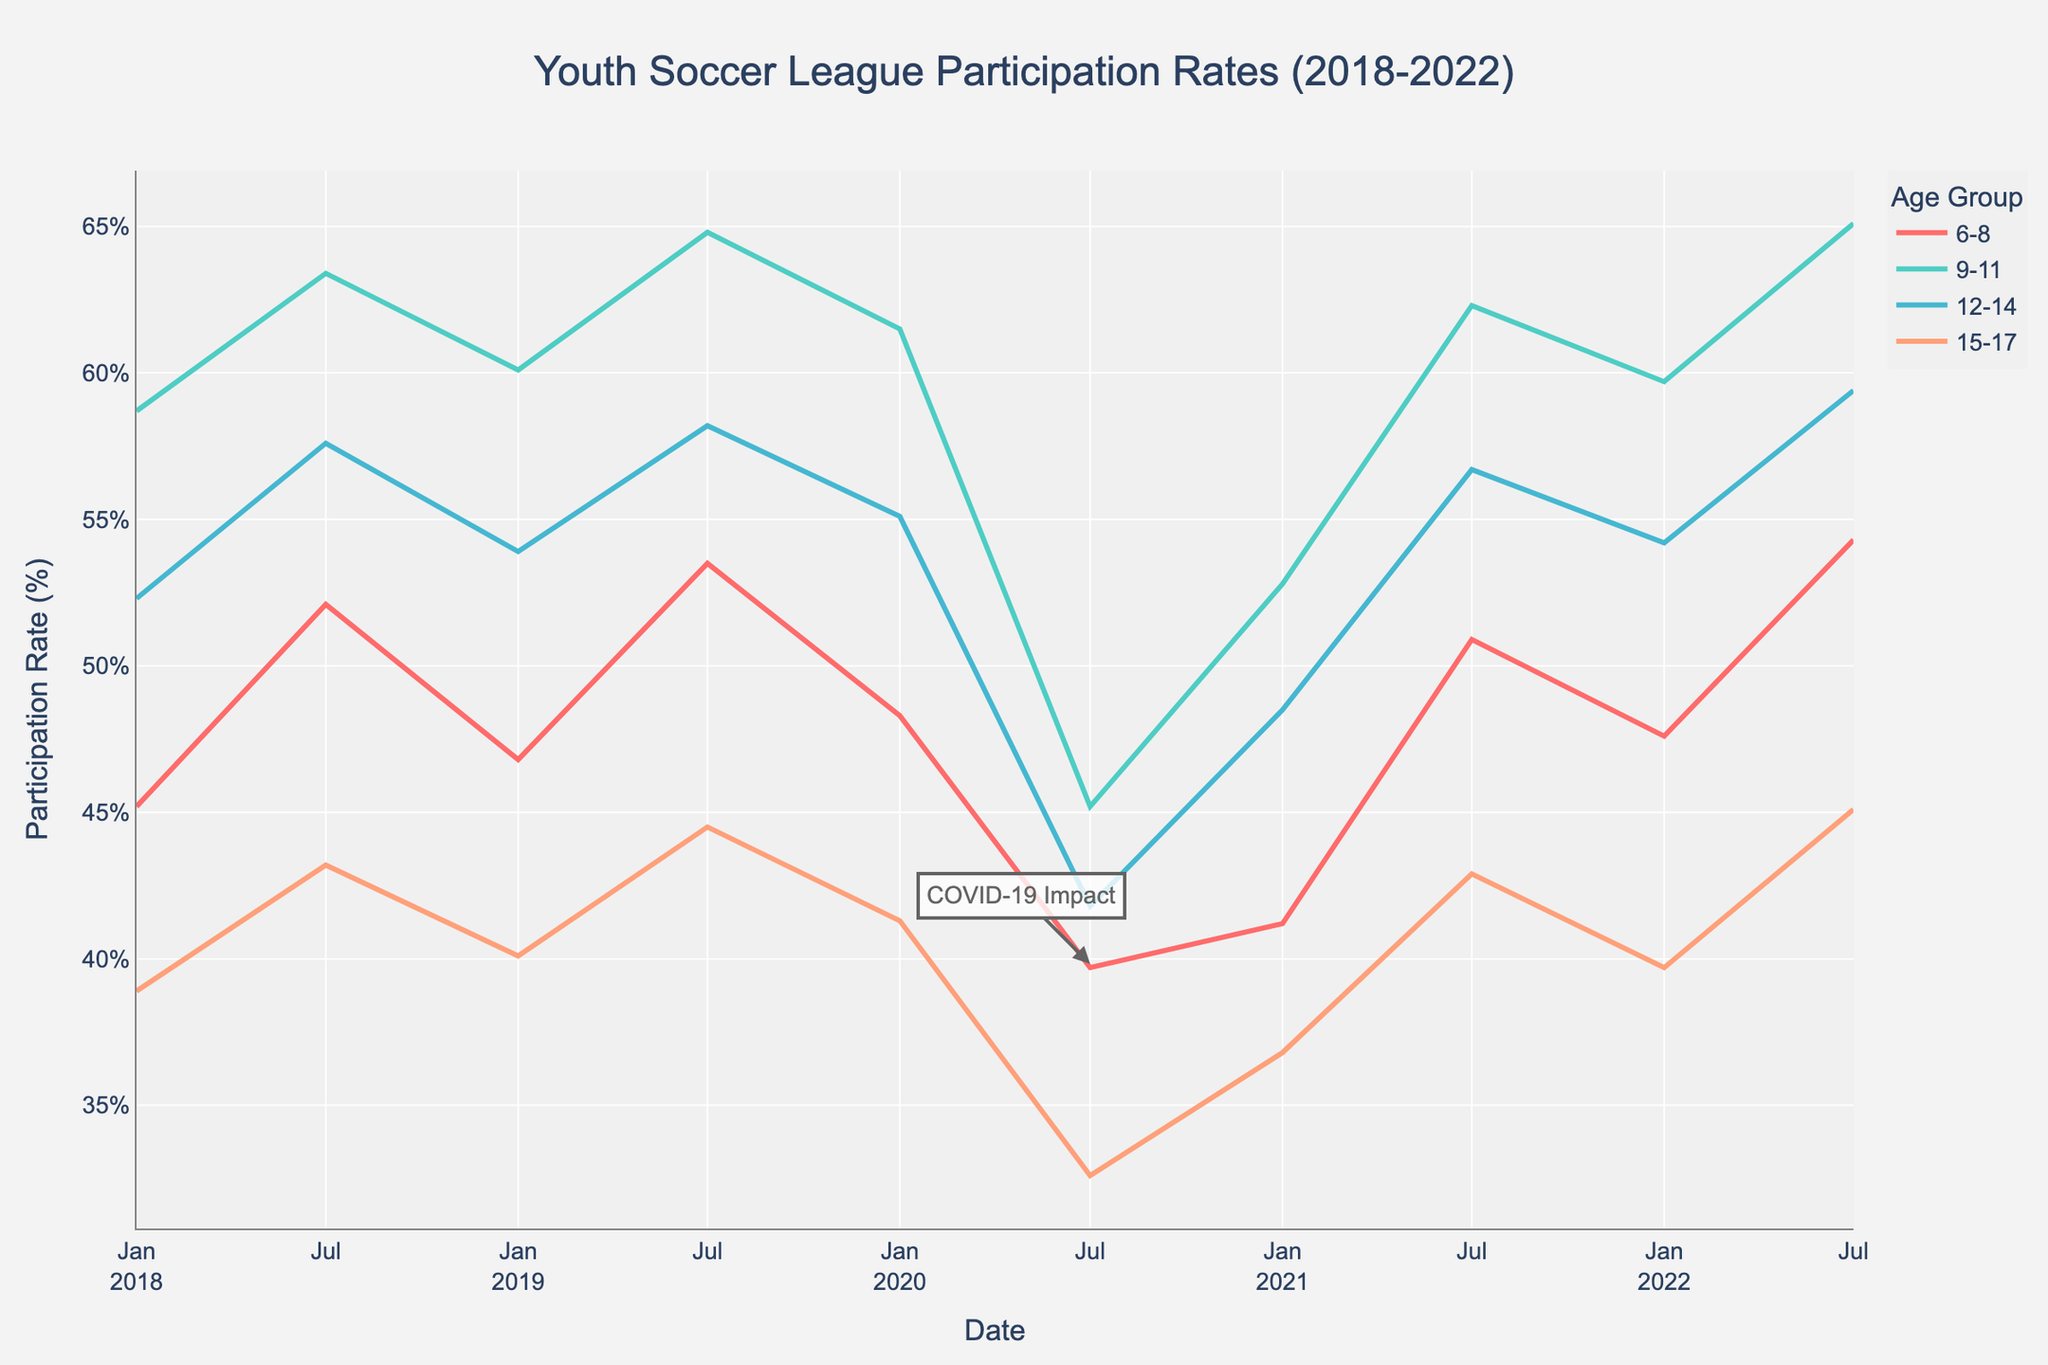Which age group had the highest participation rate in January 2019? To determine the highest participation rate in January 2019, observe the data point for each age group above January 2019. The 9-11 age group has the highest rate.
Answer: 9-11 What is the average participation rate for the 6-8 age group over the 5-year period? To calculate the average participation rate for the 6-8 age group, sum all data points and divide by the number of data points: (45.2 + 52.1 + 46.8 + 53.5 + 48.3 + 39.7 + 41.2 + 50.9 + 47.6 + 54.3) / 10 = 47.96.
Answer: 47.96 Which age group showed the most significant drop in participation rate in July 2020 compared to the previous January? Compare the participation rates from January to July 2020 for each age group. The 9-11 age group had the most significant drop (61.5% to 45.2%).
Answer: 9-11 How does the participation rate in July 2022 for the 12-14 age group compare to July 2021? Look at the data points for the 12-14 age group for July 2021 and July 2022. The participation rate increased from 56.7% to 59.4%.
Answer: increased What impact did COVID-19 appear to have on the participation rates in youth soccer leagues in July 2020? Compare the participation rates in July 2020 to other years, noting a significant decrease across all age groups, indicating the impact of COVID-19.
Answer: decreased Which age group consistently had the lowest participation rates throughout the 5 years? Observe the line patterns across all years; the 15-17 age group consistently shows the lowest participation rates.
Answer: 15-17 Calculate the difference in participation rates between the highest and lowest age groups in January 2022. Identify the highest participation rate in January 2022 (9-11 age group with 59.7%) and the lowest (15-17 age group with 39.7%), then calculate the difference: 59.7 - 39.7 = 20.
Answer: 20 Which age group demonstrated the highest growth in participation rates from July 2021 to July 2022? Compare the growth in participation rates from July 2021 to July 2022 across all age groups; the group with the highest increase is 6-8 (from 50.9 to 54.3).
Answer: 6-8 Was there any age group that showed a decrease in participation from January 2022 to July 2022? Compare the participation rates from January 2022 to July 2022 across all age groups; none show a decrease.
Answer: No 